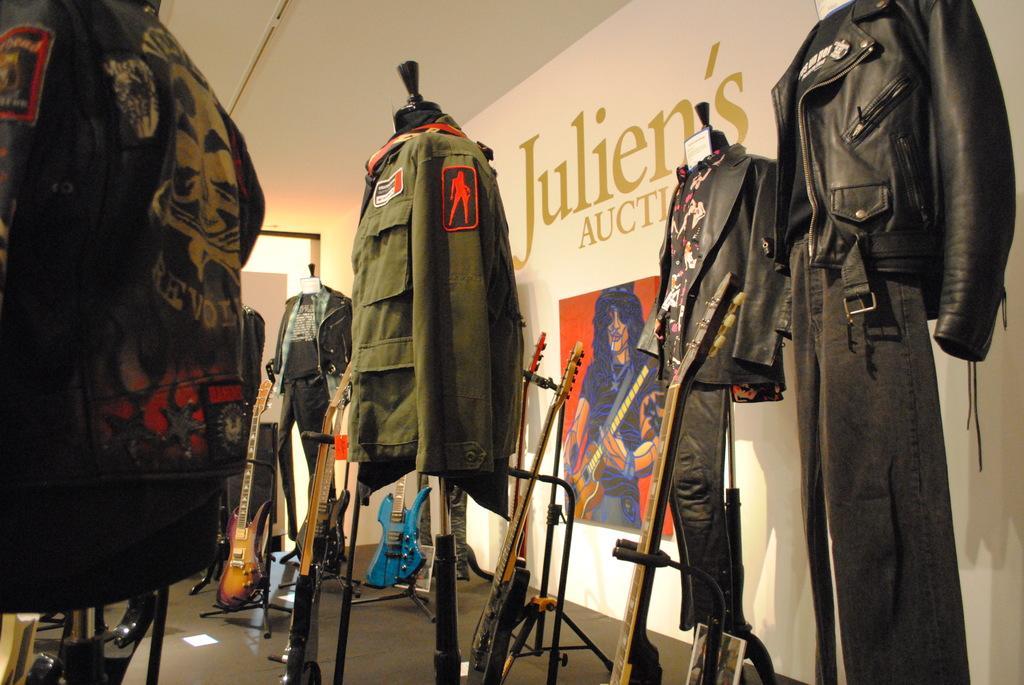Please provide a concise description of this image. In this picture we can see there are lots of clothes, guitars and stands on the floor. Behind the stands there is a wall with a photo frame. 